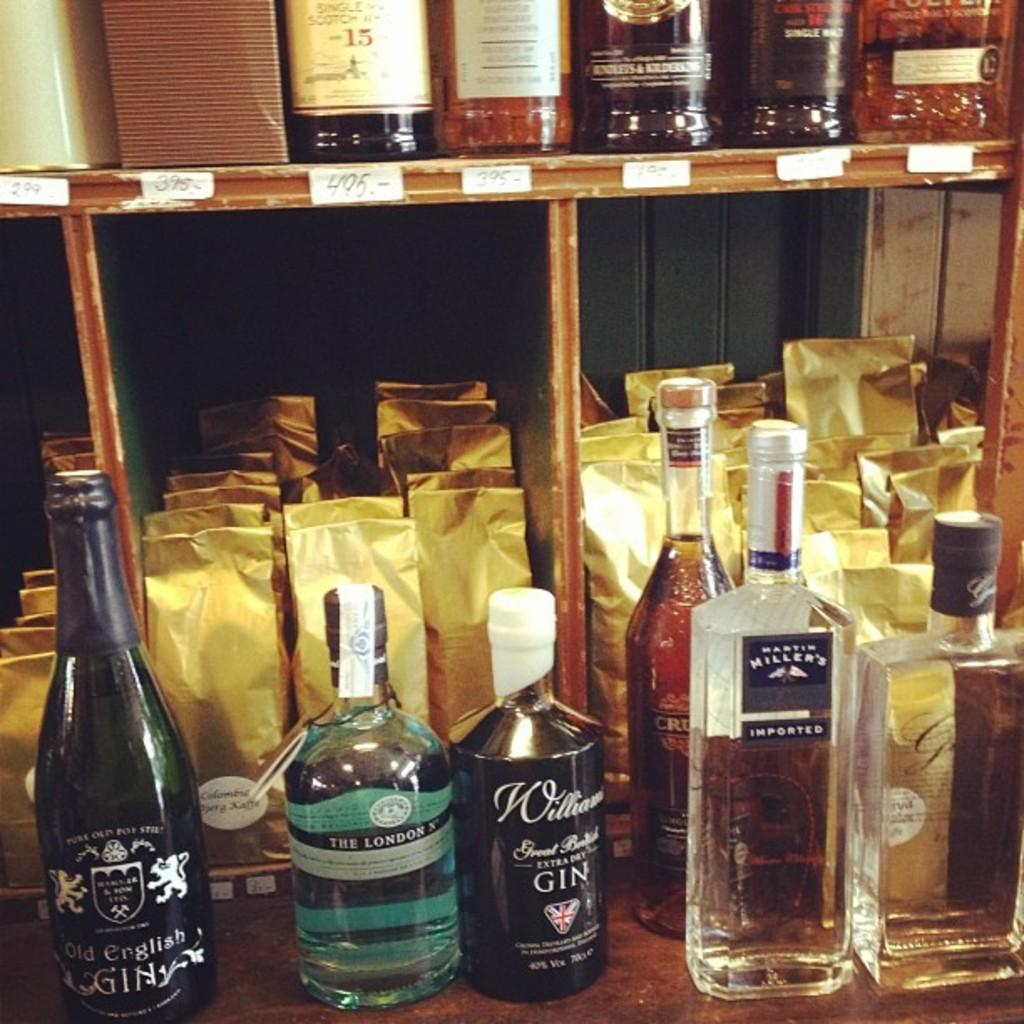<image>
Provide a brief description of the given image. One of the teal bottles on the front shelf is called "The London." 